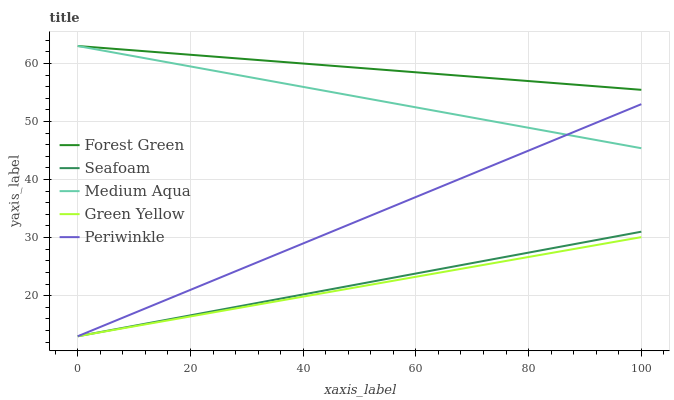Does Green Yellow have the minimum area under the curve?
Answer yes or no. Yes. Does Forest Green have the maximum area under the curve?
Answer yes or no. Yes. Does Forest Green have the minimum area under the curve?
Answer yes or no. No. Does Green Yellow have the maximum area under the curve?
Answer yes or no. No. Is Green Yellow the smoothest?
Answer yes or no. Yes. Is Forest Green the roughest?
Answer yes or no. Yes. Is Forest Green the smoothest?
Answer yes or no. No. Is Green Yellow the roughest?
Answer yes or no. No. Does Periwinkle have the lowest value?
Answer yes or no. Yes. Does Forest Green have the lowest value?
Answer yes or no. No. Does Medium Aqua have the highest value?
Answer yes or no. Yes. Does Green Yellow have the highest value?
Answer yes or no. No. Is Green Yellow less than Medium Aqua?
Answer yes or no. Yes. Is Medium Aqua greater than Seafoam?
Answer yes or no. Yes. Does Seafoam intersect Periwinkle?
Answer yes or no. Yes. Is Seafoam less than Periwinkle?
Answer yes or no. No. Is Seafoam greater than Periwinkle?
Answer yes or no. No. Does Green Yellow intersect Medium Aqua?
Answer yes or no. No. 